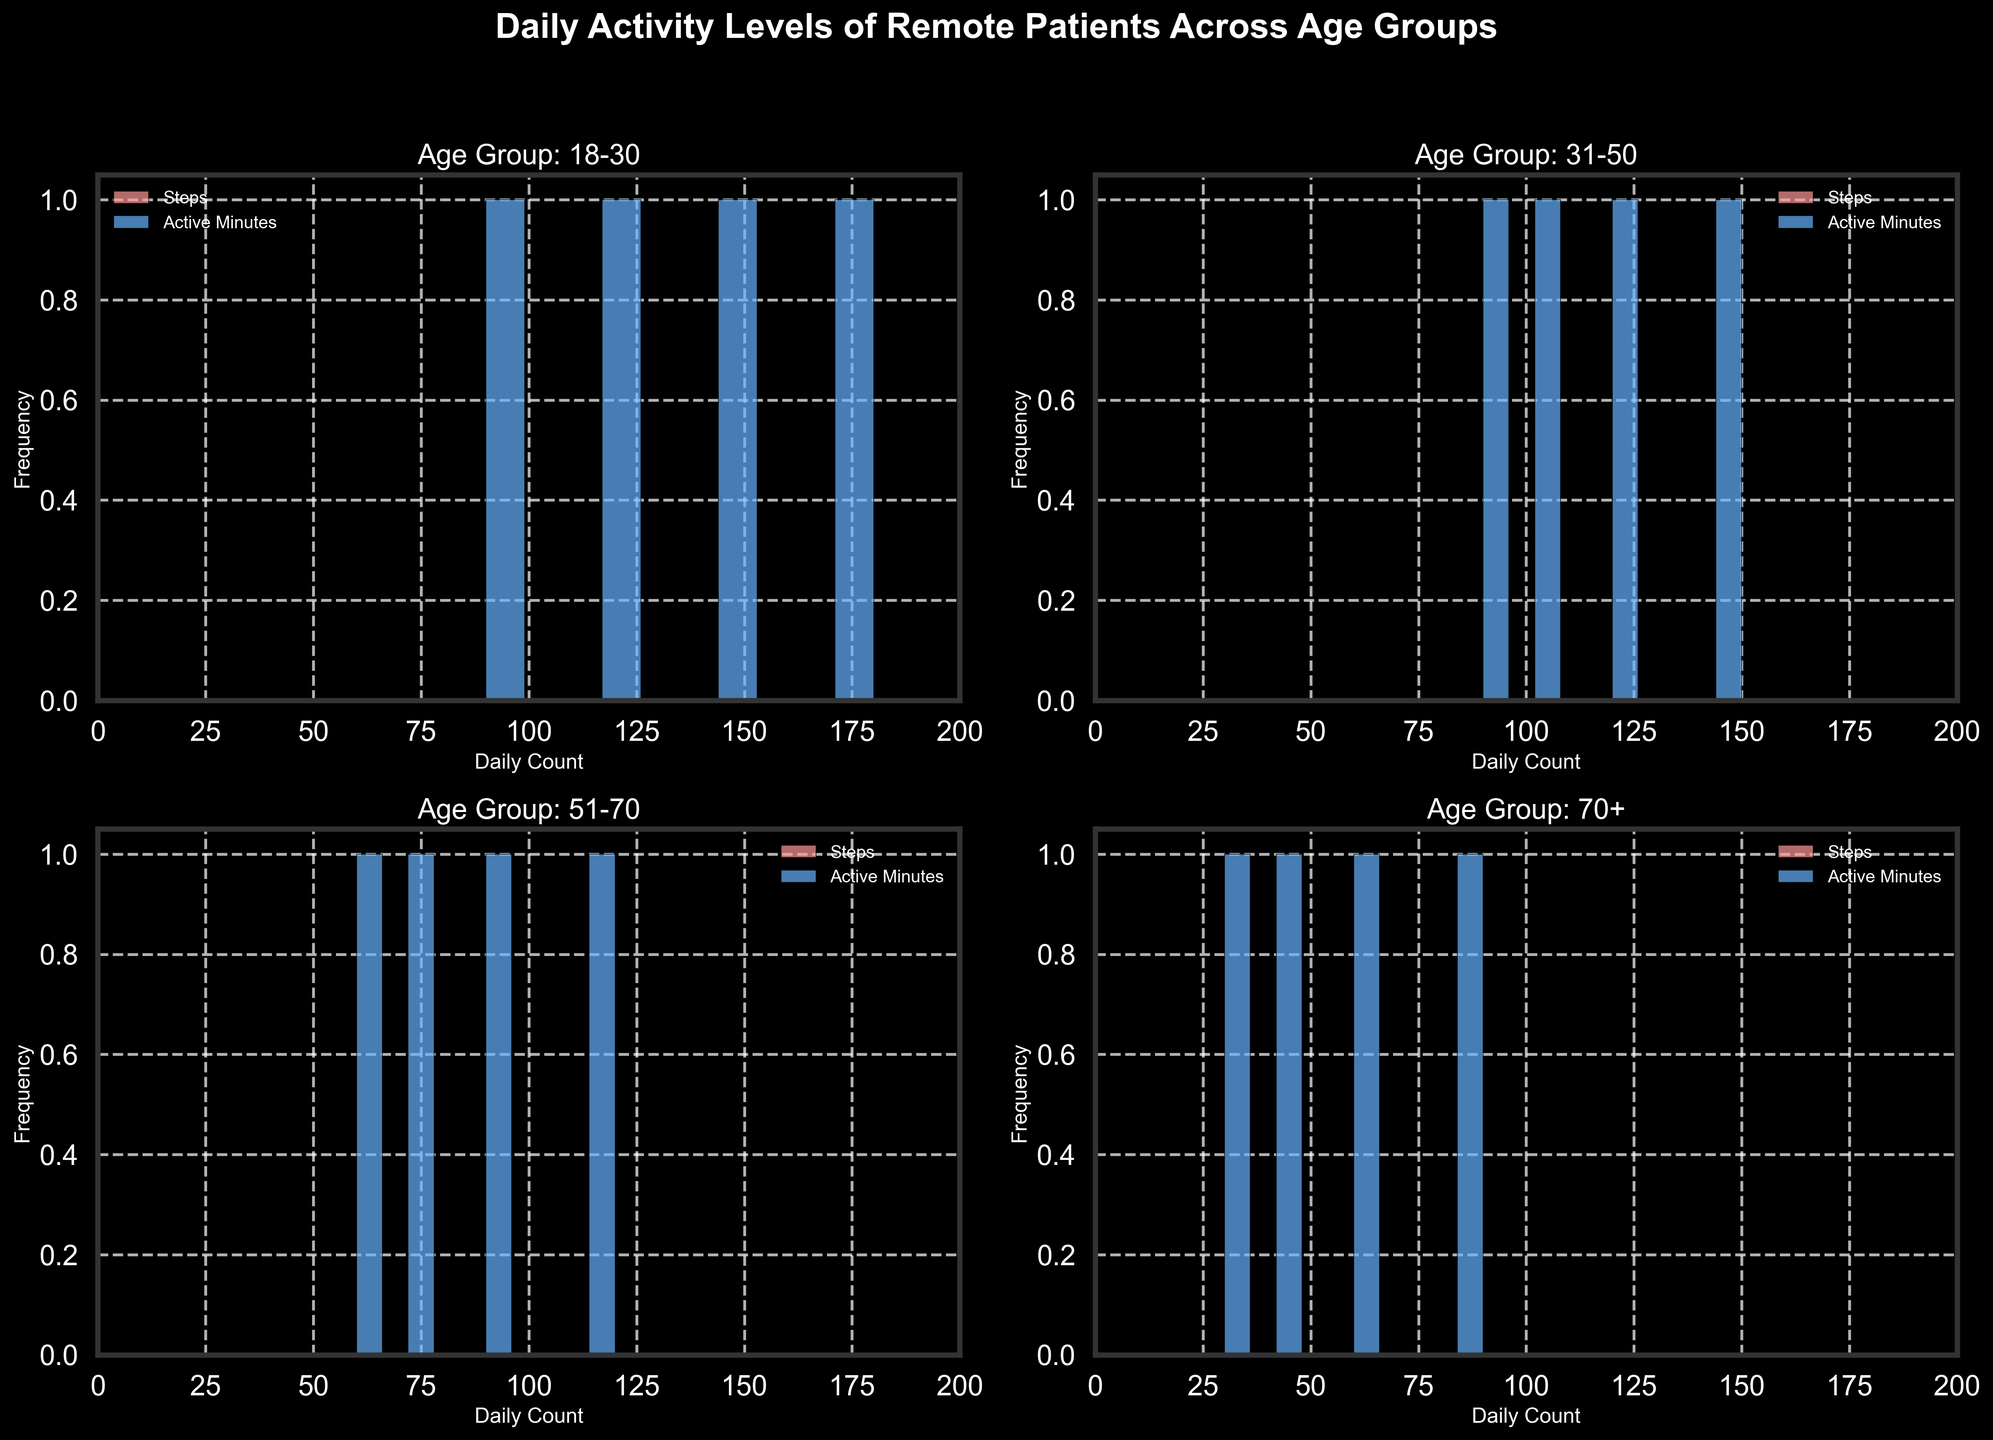What is the title of the figure? The title of the figure is displayed prominently at the top, stating the general subject of the visualization.
Answer: Daily Activity Levels of Remote Patients Across Age Groups Which age group has the widest range of daily steps? To determine the age group with the widest range of daily steps, look for the histogram with the broadest spread along the x-axis in the corresponding subplot related to "Steps" for each age group.
Answer: 18-30 What is the most frequently occurring count of active minutes for the age group 31-50? Check the "Age Group: 31-50" subplot and observe the bin in the histogram for "Active Minutes" that has the highest frequency.
Answer: 120 Which age group shows the lowest frequency of high-count steps (above 10000)? Compare the frequency of bins representing steps above 10000 in each age group's subplots. The age group with the least bars in this range has the lowest frequency.
Answer: 51-70 Are there any age groups that show a difference in the range of counts between steps and active minutes? Assess the spread of the histograms for both "Steps" and "Active Minutes" within each age group to identify any noticeable differences. The age group with a significant range difference is sought.
Answer: Yes, 70+ In the age group 51-70, what is the approximate frequency of patients with 6000 daily steps? Focus on the "Age Group: 51-70" subplot, locate the bin that includes 6000 steps, and count how tall this bin is in terms of frequency.
Answer: Approximately 1 Which age group tends to have more active minutes overall, 18-30 or 51-70? Compare the spread and the height of the histogram bins for "Active Minutes" between the subplots of "Age Group: 18-30" and "Age Group: 51-70". The group with higher and/or more frequent bins indicates more active minutes overall.
Answer: 18-30 Between the age groups 18-30 and 31-50, which one has a higher peak frequency in the Steps histogram, and what is this frequency? Examine the tallest bins in the "Steps" histograms for both age groups. Compare their heights to determine which age group has the higher peak and record its value.
Answer: 18-30, frequency approximately 1 